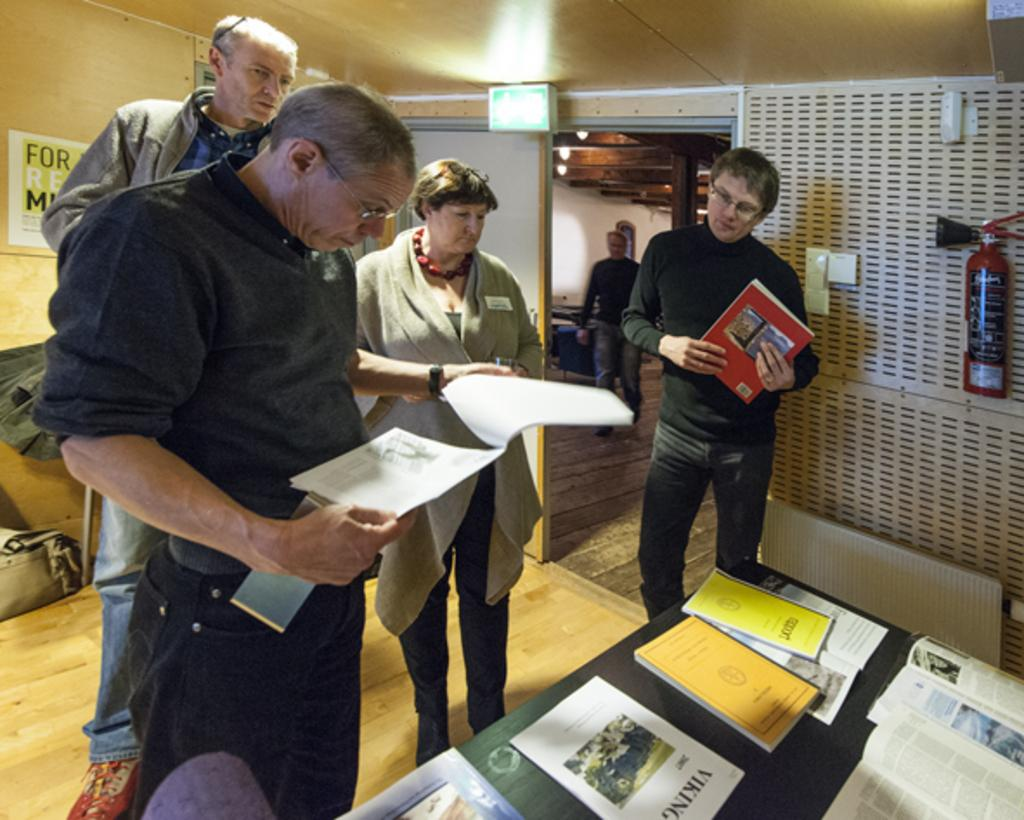<image>
Offer a succinct explanation of the picture presented. A group of people are standing in front of table that is holding various pamphlets including one on vikings. 